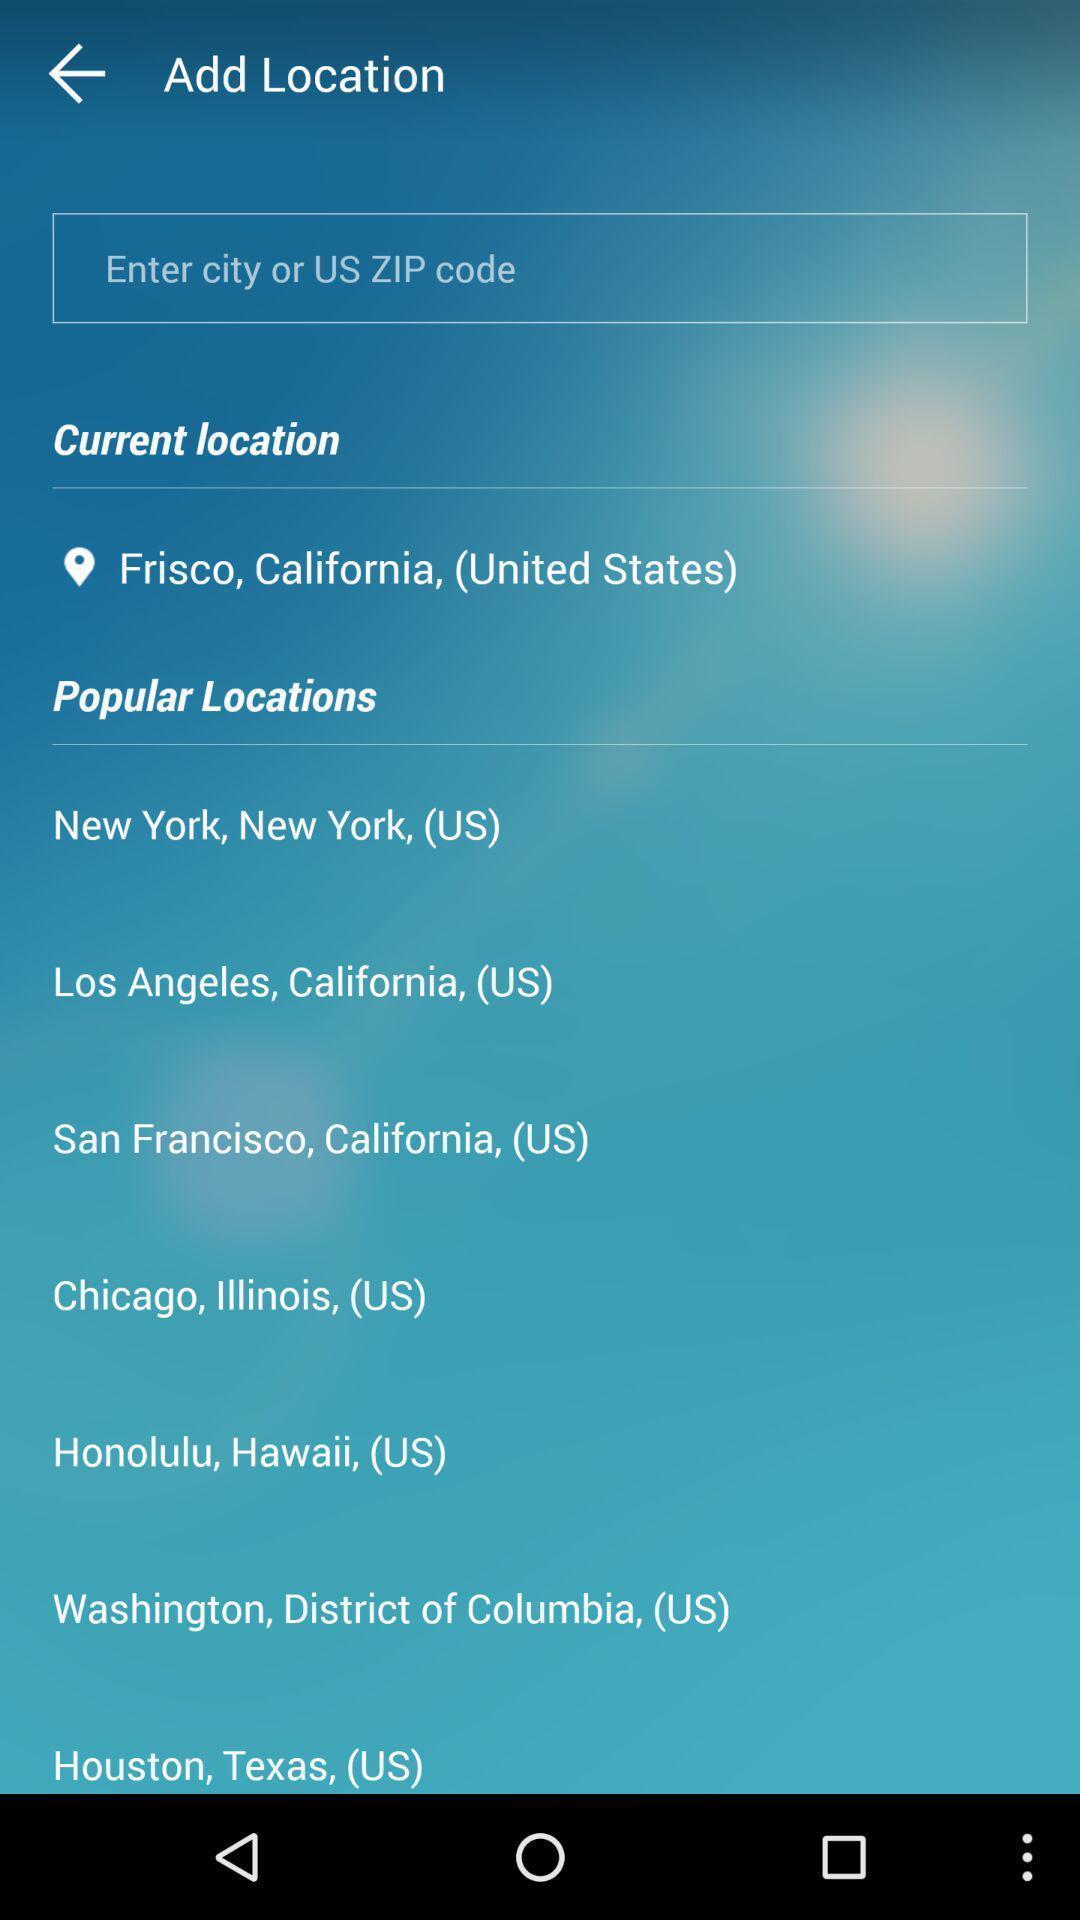Tell me what you see in this picture. Page shows to add your current location. 